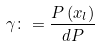<formula> <loc_0><loc_0><loc_500><loc_500>\gamma \colon = \frac { P \left ( x _ { l } \right ) } { d P }</formula> 